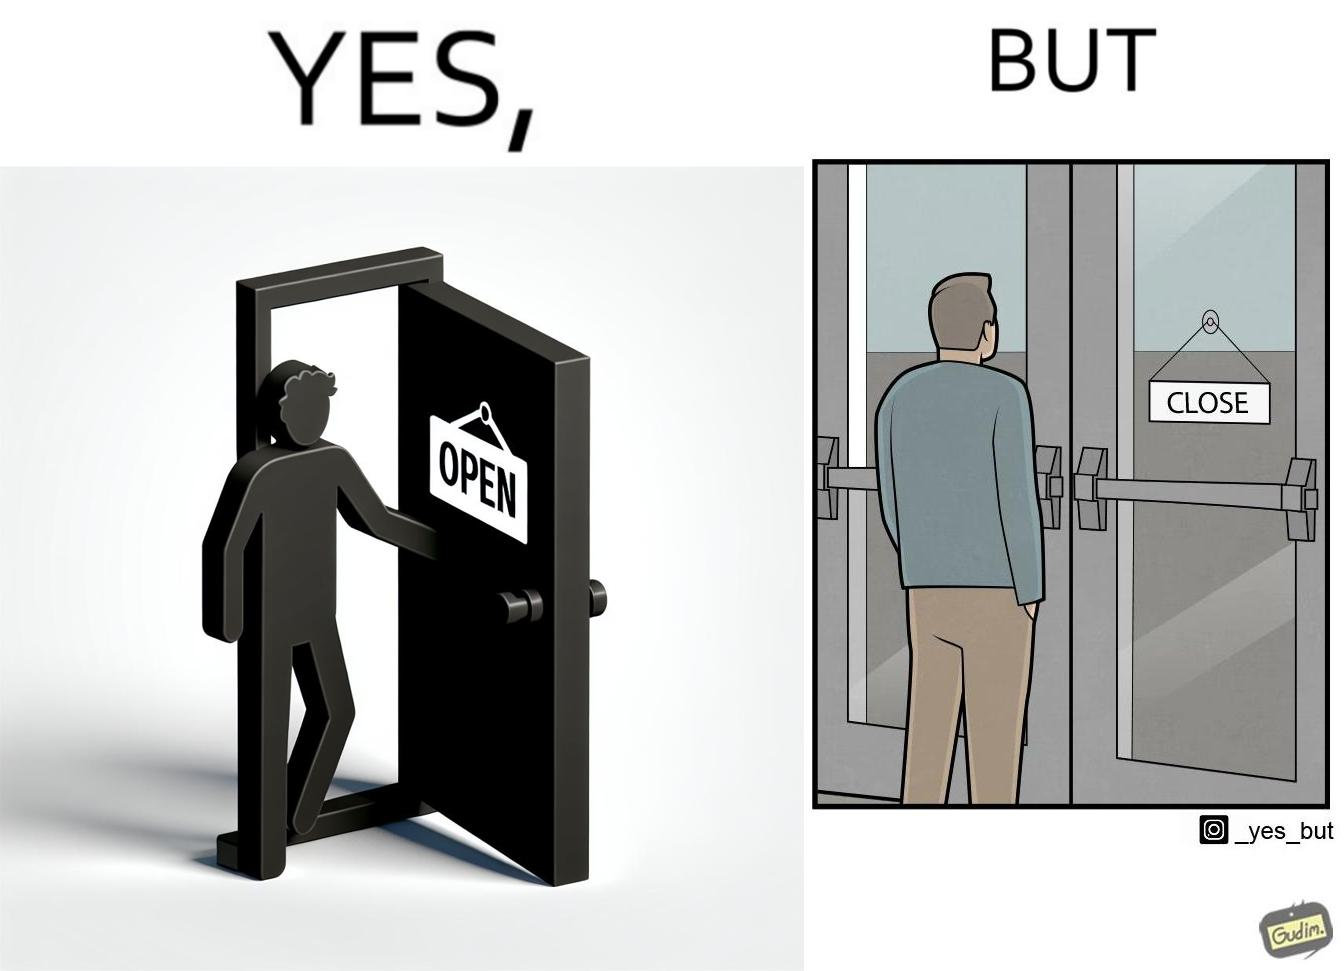What do you see in each half of this image? In the left part of the image: a person opening a door with the sign 'OPEN' In the right part of the image: a person standing near a door with the sign 'CLOSE' 